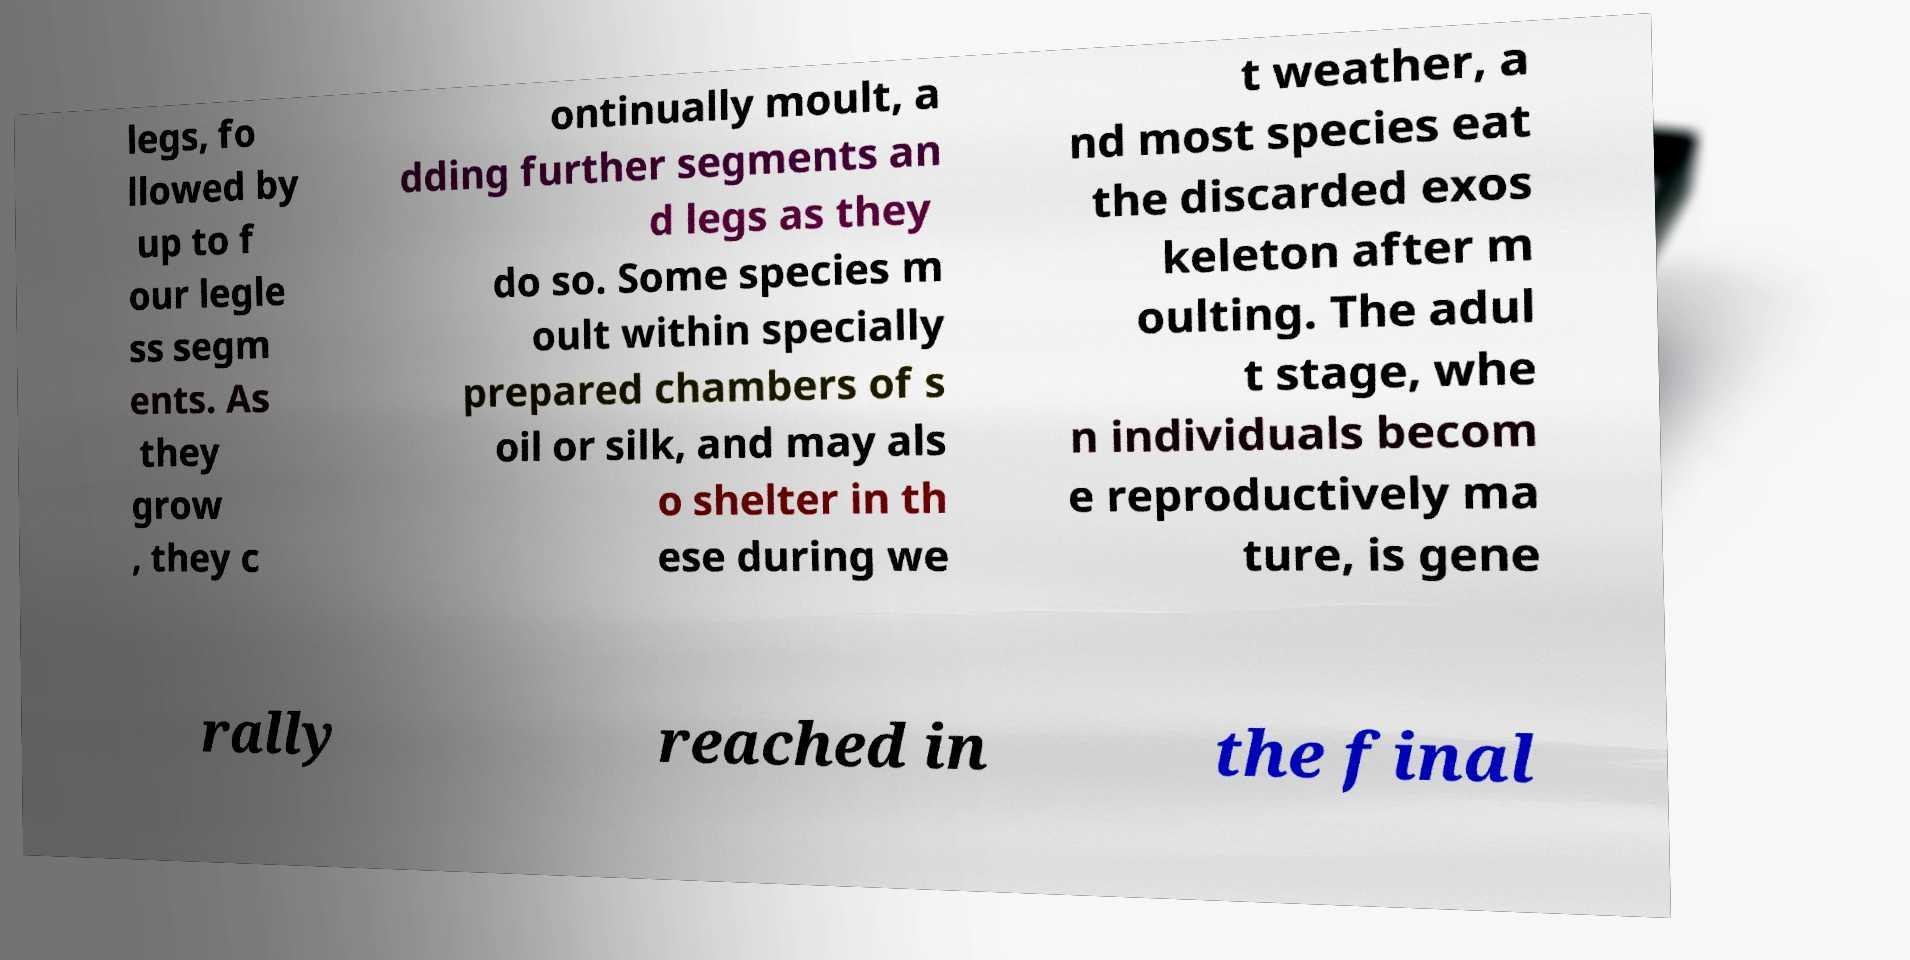Could you assist in decoding the text presented in this image and type it out clearly? legs, fo llowed by up to f our legle ss segm ents. As they grow , they c ontinually moult, a dding further segments an d legs as they do so. Some species m oult within specially prepared chambers of s oil or silk, and may als o shelter in th ese during we t weather, a nd most species eat the discarded exos keleton after m oulting. The adul t stage, whe n individuals becom e reproductively ma ture, is gene rally reached in the final 